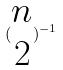Convert formula to latex. <formula><loc_0><loc_0><loc_500><loc_500>( \begin{matrix} n \\ 2 \end{matrix} ) ^ { - 1 }</formula> 